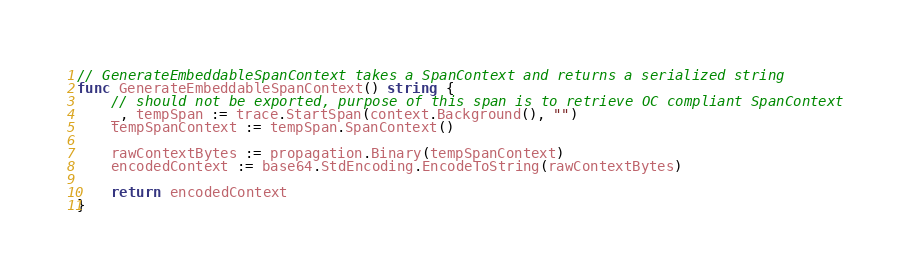Convert code to text. <code><loc_0><loc_0><loc_500><loc_500><_Go_>// GenerateEmbeddableSpanContext takes a SpanContext and returns a serialized string
func GenerateEmbeddableSpanContext() string {
	// should not be exported, purpose of this span is to retrieve OC compliant SpanContext
	_, tempSpan := trace.StartSpan(context.Background(), "")
	tempSpanContext := tempSpan.SpanContext()

	rawContextBytes := propagation.Binary(tempSpanContext)
	encodedContext := base64.StdEncoding.EncodeToString(rawContextBytes)

	return encodedContext
}
</code> 